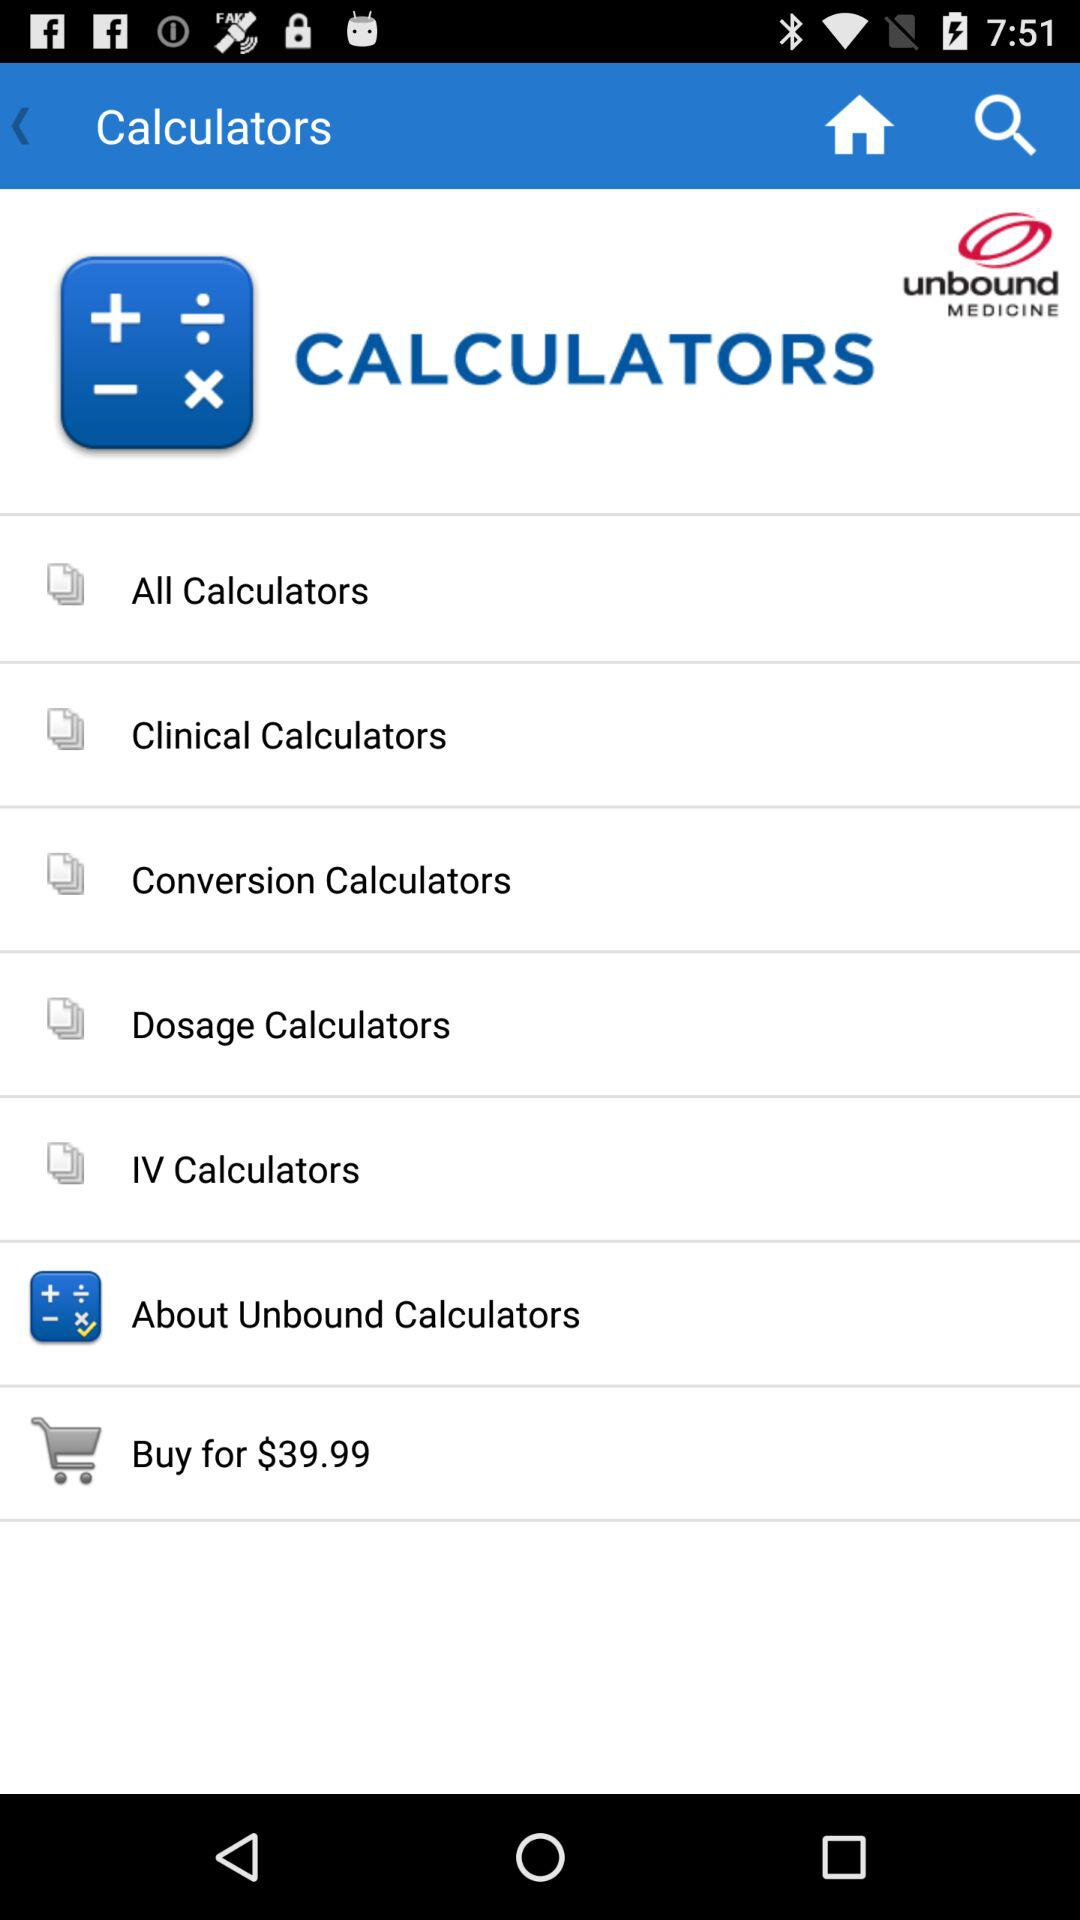How much is the price of the unbound calculator?
Answer the question using a single word or phrase. $39.99 